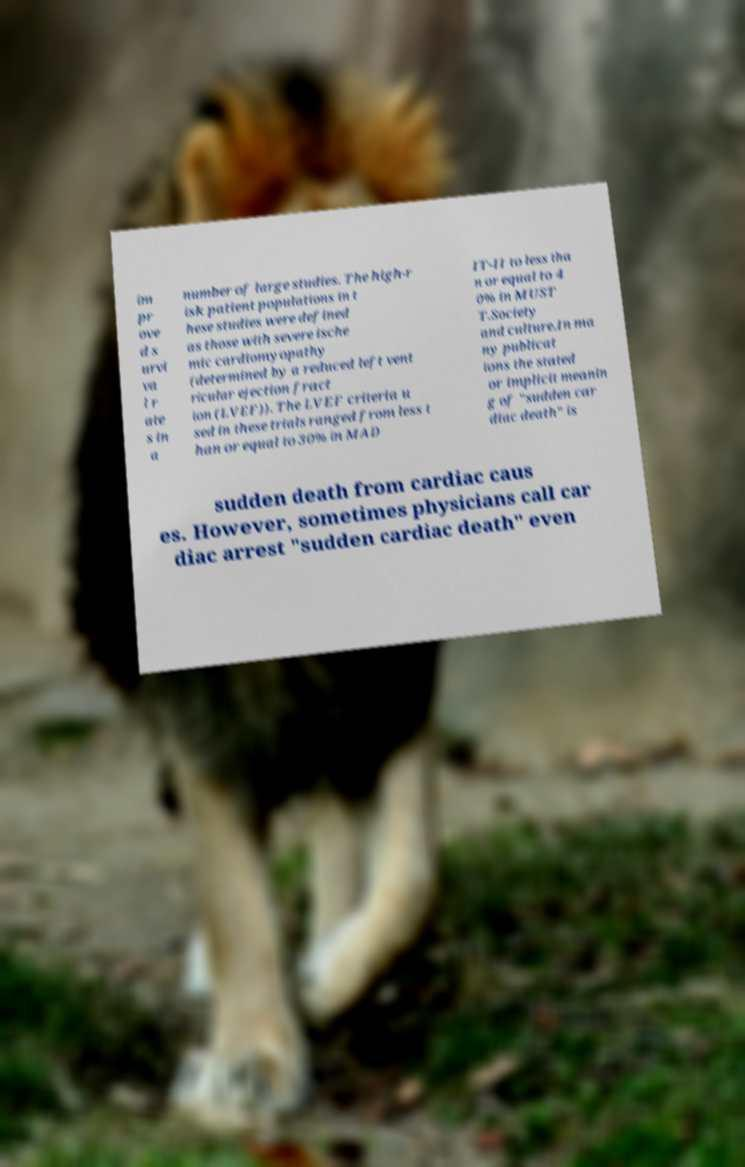Could you extract and type out the text from this image? im pr ove d s urvi va l r ate s in a number of large studies. The high-r isk patient populations in t hese studies were defined as those with severe ische mic cardiomyopathy (determined by a reduced left vent ricular ejection fract ion (LVEF)). The LVEF criteria u sed in these trials ranged from less t han or equal to 30% in MAD IT-II to less tha n or equal to 4 0% in MUST T.Society and culture.In ma ny publicat ions the stated or implicit meanin g of "sudden car diac death" is sudden death from cardiac caus es. However, sometimes physicians call car diac arrest "sudden cardiac death" even 